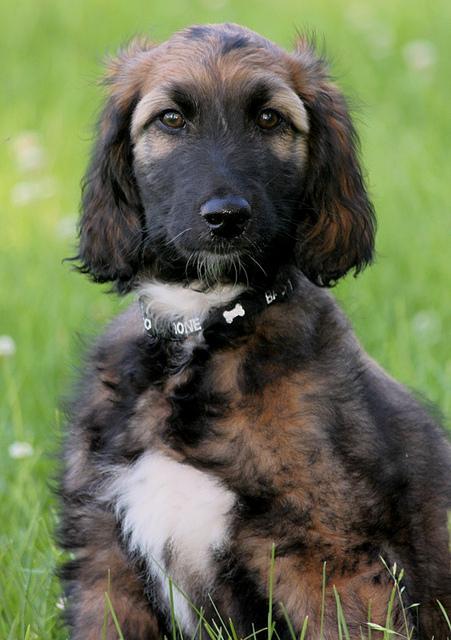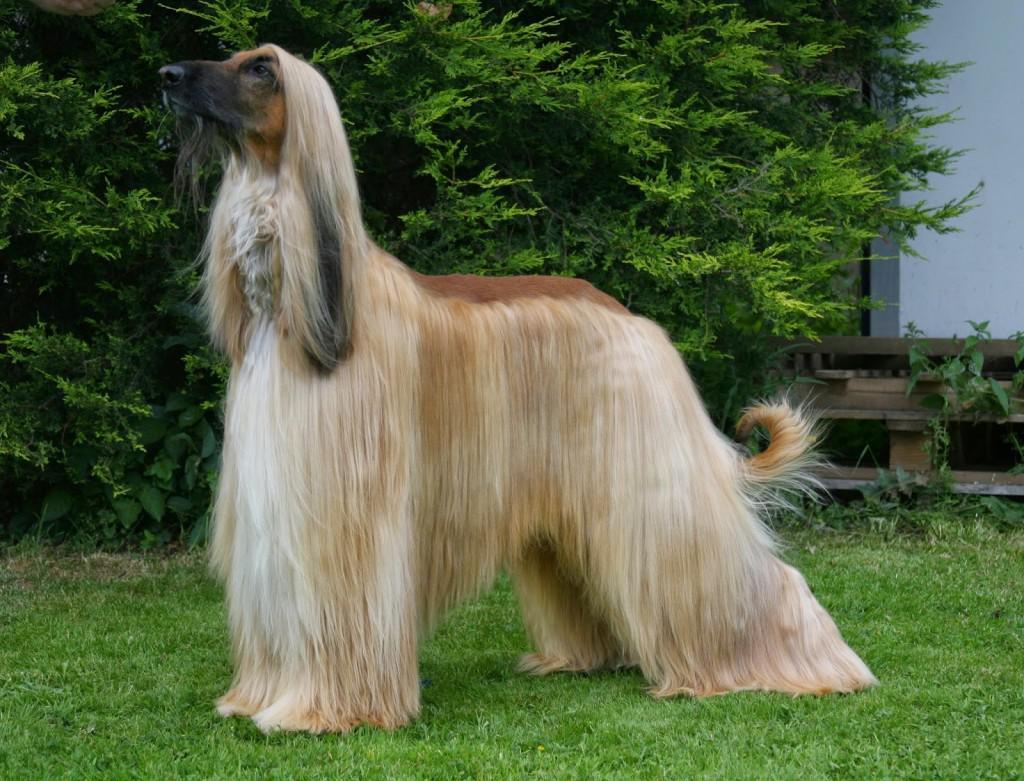The first image is the image on the left, the second image is the image on the right. Examine the images to the left and right. Is the description "One dog is looking left and one dog is looking straight ahead." accurate? Answer yes or no. Yes. 